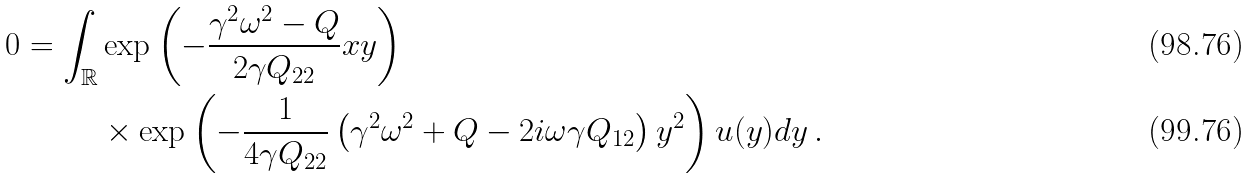Convert formula to latex. <formula><loc_0><loc_0><loc_500><loc_500>0 = \int _ { \mathbb { R } } & \exp \left ( - \frac { \gamma ^ { 2 } \omega ^ { 2 } - Q } { 2 \gamma Q _ { 2 2 } } x y \right ) \\ & \times \exp \left ( - \frac { 1 } { 4 \gamma Q _ { 2 2 } } \left ( \gamma ^ { 2 } \omega ^ { 2 } + Q - 2 i \omega \gamma Q _ { 1 2 } \right ) y ^ { 2 } \right ) u ( y ) d y \, .</formula> 